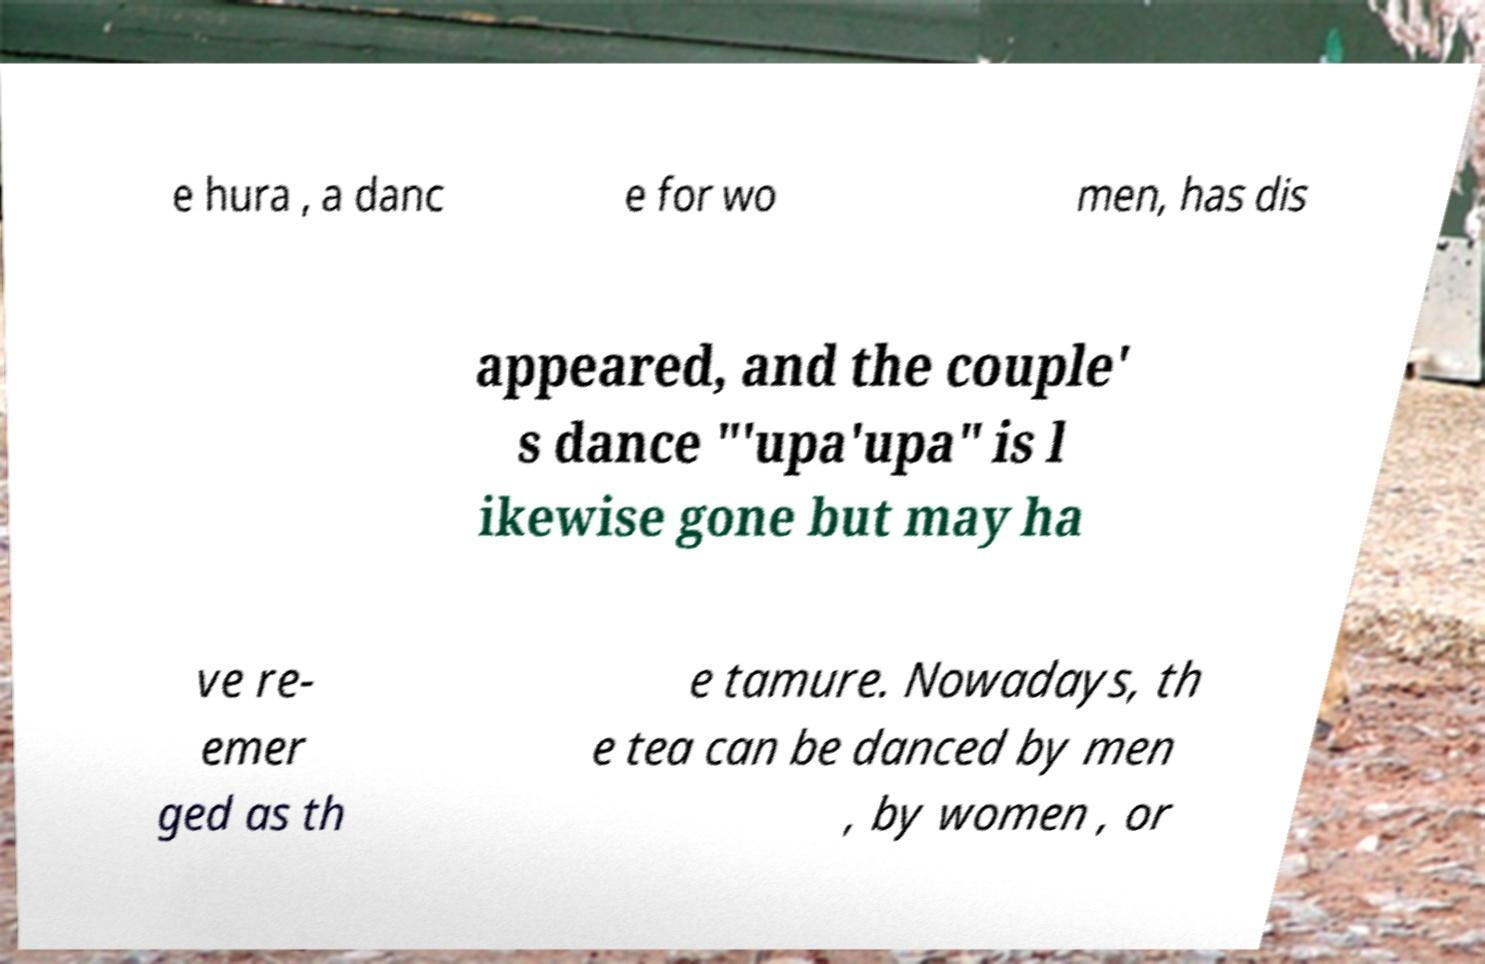Could you extract and type out the text from this image? e hura , a danc e for wo men, has dis appeared, and the couple' s dance "'upa'upa" is l ikewise gone but may ha ve re- emer ged as th e tamure. Nowadays, th e tea can be danced by men , by women , or 